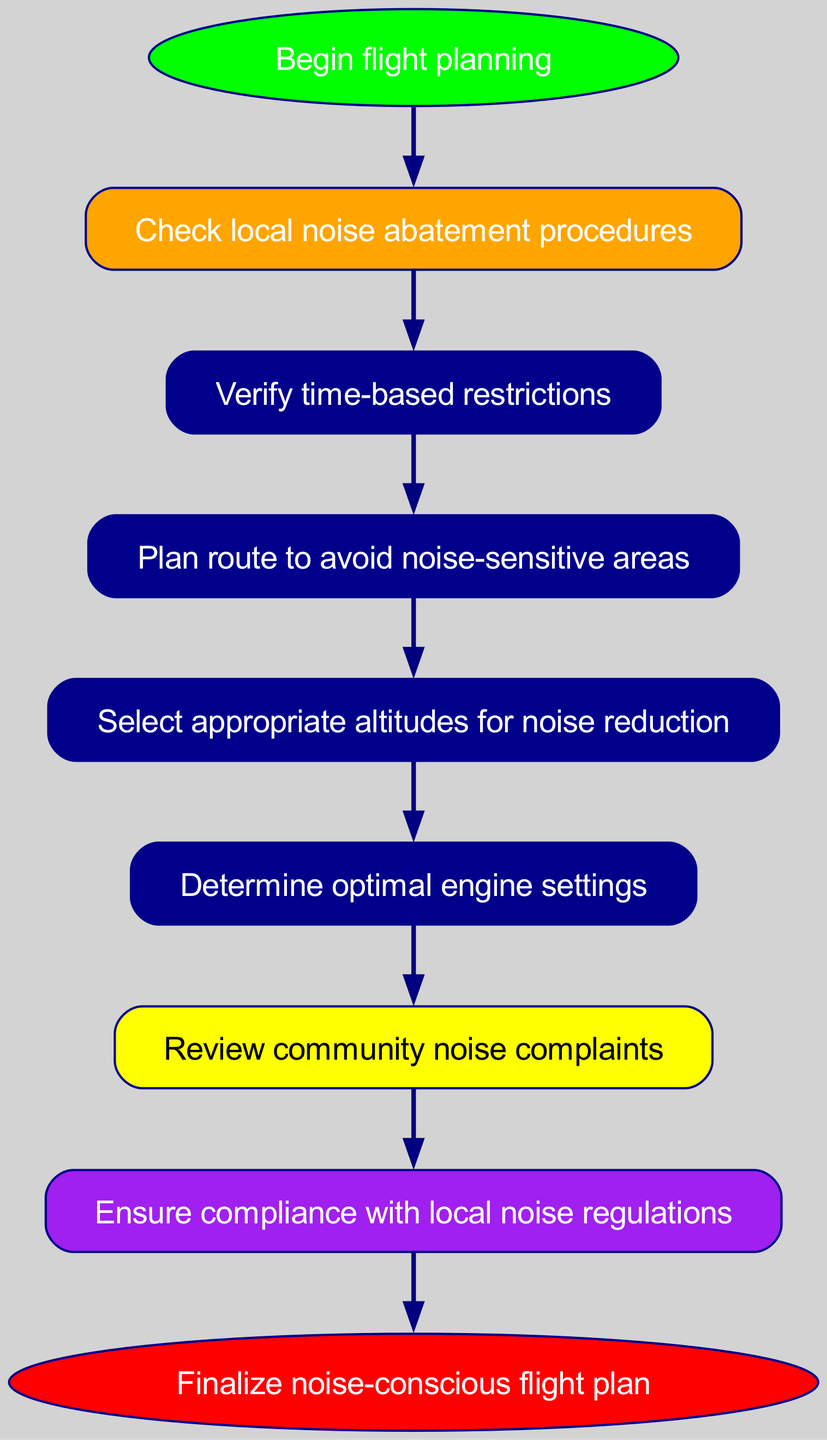What is the first step in the flight planning process? The first step in the flowchart is labeled "Begin flight planning." It is the starting point of the process, indicating the initiation of the flight planning activities.
Answer: Begin flight planning How many total nodes are in the diagram? The diagram consists of ten nodes representing different steps in the flight planning process. Counting each labeled step, there are eight main steps plus the start and end nodes, leading to a total of ten nodes.
Answer: 10 What action follows the review of community noise complaints? According to the flowchart, after reviewing community noise complaints, the next action is to "Ensure compliance with local noise regulations." This shows a direct progression from community feedback to ensuring regulatory adherence.
Answer: Ensure compliance with local noise regulations What type of node is at the end of the process? The end node is labeled "Finalize noise-conscious flight plan" and is depicted as an ellipse with a red fill color, indicating the conclusion of the flight planning process.
Answer: Finalize noise-conscious flight plan What is the relationship between checking local noise abatement procedures and verifying time-based restrictions? In the flowchart, checking local noise abatement procedures directly leads to verifying time-based restrictions. It shows that verifying time restrictions is a step that needs to be taken after reviewing noise abatement procedures.
Answer: Verify time-based restrictions What color represents nodes related to community feedback? The node related to community feedback is colored yellow, which is designed to stand out and draw attention to the importance of community input in noise management.
Answer: Yellow What must be done before selecting appropriate altitudes for noise reduction? Before selecting appropriate altitudes, the flowchart indicates that one must first "Plan route to avoid noise-sensitive areas." This means that route planning is a prerequisite for altitude selection.
Answer: Plan route to avoid noise-sensitive areas Is there a direct link from verifying time-based restrictions to any action? Yes, the flowchart shows a direct link from verifying time-based restrictions to "Plan route to avoid noise-sensitive areas." This indicates that time restrictions influence route planning decisions.
Answer: Plan route to avoid noise-sensitive areas Which step comes just before ensuring compliance with local noise regulations? The step that comes immediately before ensuring compliance with local noise regulations is "Review community noise complaints." This implies that feedback from the community is considered before confirming regulatory compliance.
Answer: Review community noise complaints 